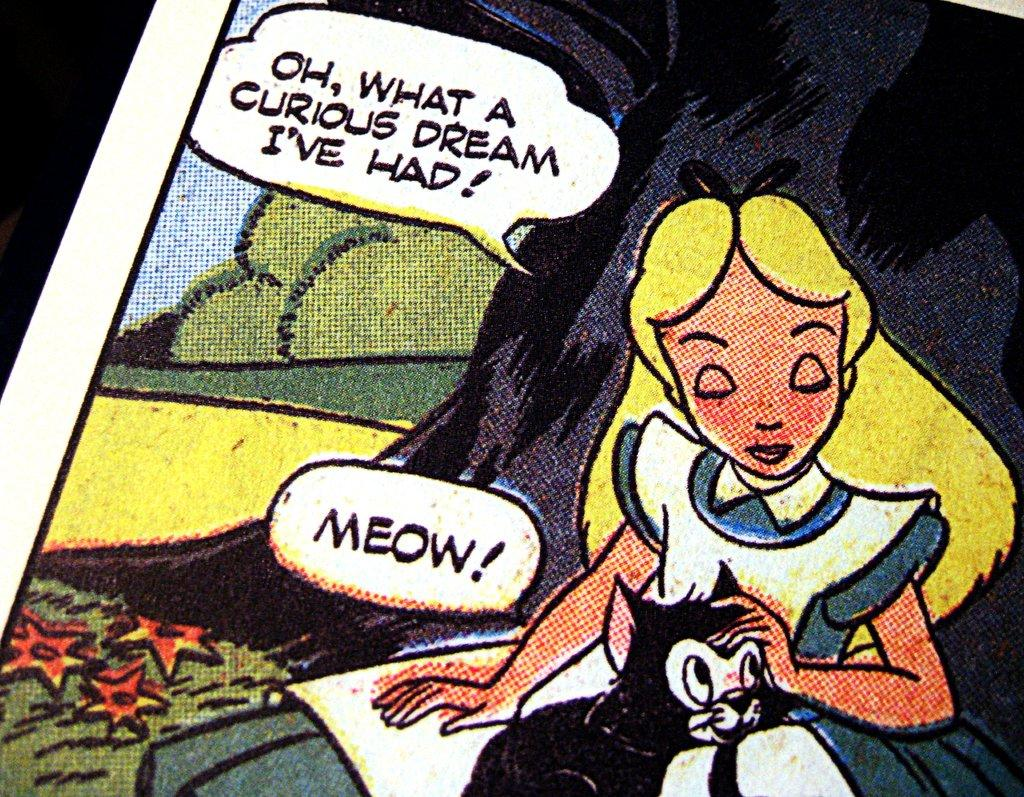What is the main subject of the image? The main subject of the image is painted paper. What can be found on the painted paper? The painted paper contains images and text. What type of authority is depicted in the image? There is no authority depicted in the image; it features painted paper with images and text. What kind of metal can be seen in the image? There is no metal present in the image; it features painted paper with images and text. 